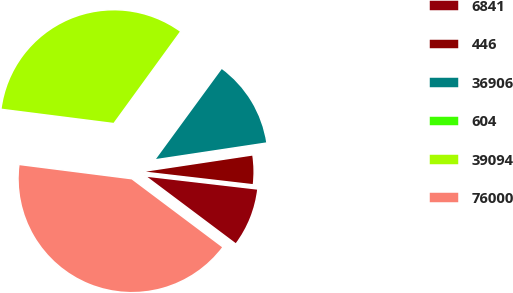<chart> <loc_0><loc_0><loc_500><loc_500><pie_chart><fcel>6841<fcel>446<fcel>36906<fcel>604<fcel>39094<fcel>76000<nl><fcel>8.4%<fcel>4.22%<fcel>12.57%<fcel>0.05%<fcel>32.99%<fcel>41.77%<nl></chart> 